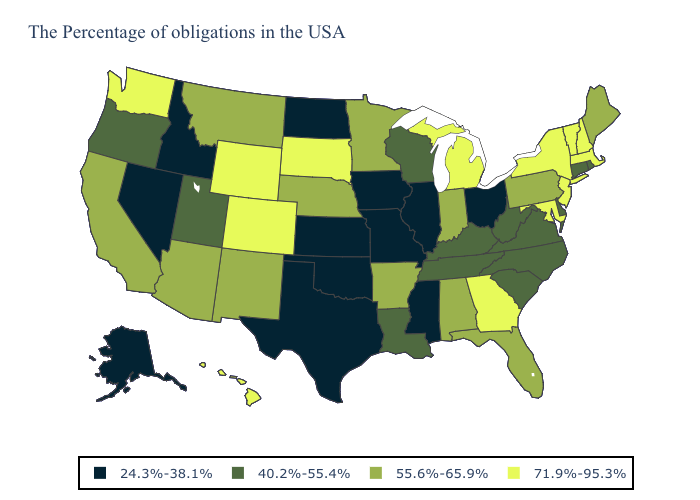What is the highest value in the USA?
Answer briefly. 71.9%-95.3%. Name the states that have a value in the range 40.2%-55.4%?
Keep it brief. Rhode Island, Connecticut, Delaware, Virginia, North Carolina, South Carolina, West Virginia, Kentucky, Tennessee, Wisconsin, Louisiana, Utah, Oregon. What is the highest value in the USA?
Concise answer only. 71.9%-95.3%. What is the value of Minnesota?
Give a very brief answer. 55.6%-65.9%. Name the states that have a value in the range 24.3%-38.1%?
Keep it brief. Ohio, Illinois, Mississippi, Missouri, Iowa, Kansas, Oklahoma, Texas, North Dakota, Idaho, Nevada, Alaska. Does Mississippi have the lowest value in the USA?
Quick response, please. Yes. Does Hawaii have the highest value in the USA?
Be succinct. Yes. Does the map have missing data?
Give a very brief answer. No. What is the lowest value in the Northeast?
Be succinct. 40.2%-55.4%. Name the states that have a value in the range 40.2%-55.4%?
Be succinct. Rhode Island, Connecticut, Delaware, Virginia, North Carolina, South Carolina, West Virginia, Kentucky, Tennessee, Wisconsin, Louisiana, Utah, Oregon. Is the legend a continuous bar?
Give a very brief answer. No. Which states have the highest value in the USA?
Be succinct. Massachusetts, New Hampshire, Vermont, New York, New Jersey, Maryland, Georgia, Michigan, South Dakota, Wyoming, Colorado, Washington, Hawaii. What is the value of Idaho?
Short answer required. 24.3%-38.1%. Does Nevada have a higher value than Texas?
Short answer required. No. What is the highest value in states that border Delaware?
Quick response, please. 71.9%-95.3%. 